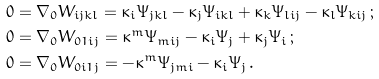<formula> <loc_0><loc_0><loc_500><loc_500>& 0 = \nabla _ { 0 } W _ { i j k l } = \kappa _ { i } \Psi _ { j k l } - \kappa _ { j } \Psi _ { i k l } + \kappa _ { k } \Psi _ { l i j } - \kappa _ { l } \Psi _ { k i j } \, ; \\ & 0 = \nabla _ { 0 } W _ { 0 1 i j } = \kappa ^ { m } \Psi _ { m i j } - \kappa _ { i } \Psi _ { j } + \kappa _ { j } \Psi _ { i } \, ; \\ & 0 = \nabla _ { 0 } W _ { 0 i 1 j } = - \kappa ^ { m } \Psi _ { j m i } - \kappa _ { i } \Psi _ { j } \, .</formula> 